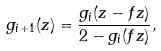<formula> <loc_0><loc_0><loc_500><loc_500>g _ { i + 1 } ( z ) = \frac { g _ { i } ( z - f z ) } { 2 - g _ { i } ( f z ) } ,</formula> 